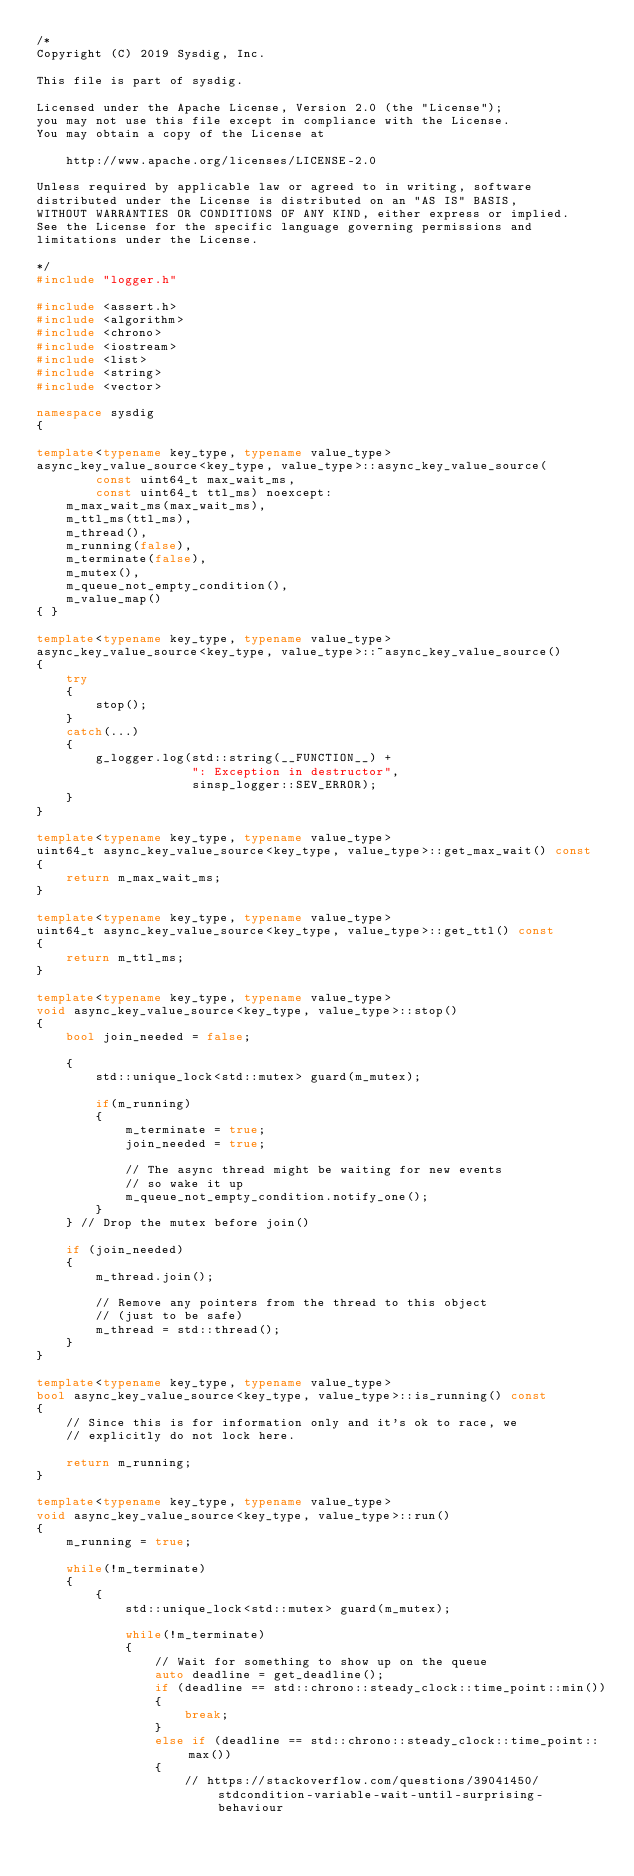<code> <loc_0><loc_0><loc_500><loc_500><_C++_>/*
Copyright (C) 2019 Sysdig, Inc.

This file is part of sysdig.

Licensed under the Apache License, Version 2.0 (the "License");
you may not use this file except in compliance with the License.
You may obtain a copy of the License at

    http://www.apache.org/licenses/LICENSE-2.0

Unless required by applicable law or agreed to in writing, software
distributed under the License is distributed on an "AS IS" BASIS,
WITHOUT WARRANTIES OR CONDITIONS OF ANY KIND, either express or implied.
See the License for the specific language governing permissions and
limitations under the License.

*/
#include "logger.h"

#include <assert.h>
#include <algorithm>
#include <chrono>
#include <iostream>
#include <list>
#include <string>
#include <vector>

namespace sysdig
{

template<typename key_type, typename value_type>
async_key_value_source<key_type, value_type>::async_key_value_source(
		const uint64_t max_wait_ms,
		const uint64_t ttl_ms) noexcept:
	m_max_wait_ms(max_wait_ms),
	m_ttl_ms(ttl_ms),
	m_thread(),
	m_running(false),
	m_terminate(false),
	m_mutex(),
	m_queue_not_empty_condition(),
	m_value_map()
{ }

template<typename key_type, typename value_type>
async_key_value_source<key_type, value_type>::~async_key_value_source()
{
	try
	{
		stop();
	}
	catch(...)
	{
		g_logger.log(std::string(__FUNCTION__) +
		             ": Exception in destructor",
		             sinsp_logger::SEV_ERROR);
	}
}

template<typename key_type, typename value_type>
uint64_t async_key_value_source<key_type, value_type>::get_max_wait() const
{
	return m_max_wait_ms;
}

template<typename key_type, typename value_type>
uint64_t async_key_value_source<key_type, value_type>::get_ttl() const
{
	return m_ttl_ms;
}

template<typename key_type, typename value_type>
void async_key_value_source<key_type, value_type>::stop()
{
	bool join_needed = false;

	{
		std::unique_lock<std::mutex> guard(m_mutex);

		if(m_running)
		{
			m_terminate = true;
			join_needed = true;

			// The async thread might be waiting for new events
			// so wake it up
			m_queue_not_empty_condition.notify_one();
		}
	} // Drop the mutex before join()

	if (join_needed)
	{
		m_thread.join();

		// Remove any pointers from the thread to this object
		// (just to be safe)
		m_thread = std::thread();
	}
}

template<typename key_type, typename value_type>
bool async_key_value_source<key_type, value_type>::is_running() const
{
	// Since this is for information only and it's ok to race, we
	// explicitly do not lock here.

	return m_running;
}

template<typename key_type, typename value_type>
void async_key_value_source<key_type, value_type>::run()
{
	m_running = true;

	while(!m_terminate)
	{
		{
			std::unique_lock<std::mutex> guard(m_mutex);

			while(!m_terminate)
			{
				// Wait for something to show up on the queue
				auto deadline = get_deadline();
				if (deadline == std::chrono::steady_clock::time_point::min())
				{
					break;
				}
				else if (deadline == std::chrono::steady_clock::time_point::max())
				{
					// https://stackoverflow.com/questions/39041450/stdcondition-variable-wait-until-surprising-behaviour</code> 